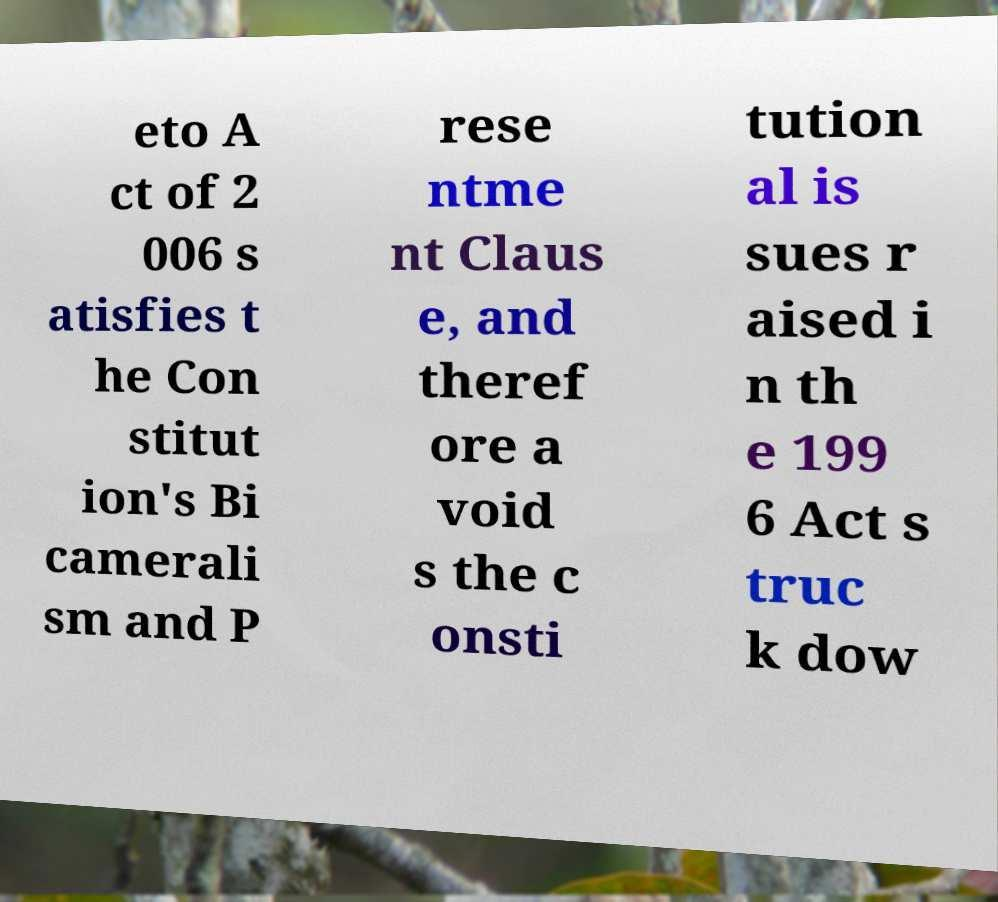There's text embedded in this image that I need extracted. Can you transcribe it verbatim? eto A ct of 2 006 s atisfies t he Con stitut ion's Bi camerali sm and P rese ntme nt Claus e, and theref ore a void s the c onsti tution al is sues r aised i n th e 199 6 Act s truc k dow 